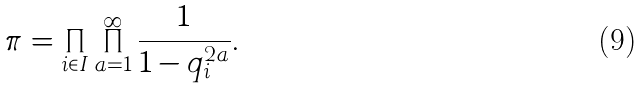<formula> <loc_0><loc_0><loc_500><loc_500>\pi = \prod _ { i \in I } \prod _ { a = 1 } ^ { \infty } \frac { 1 } { 1 - q _ { i } ^ { 2 a } } .</formula> 